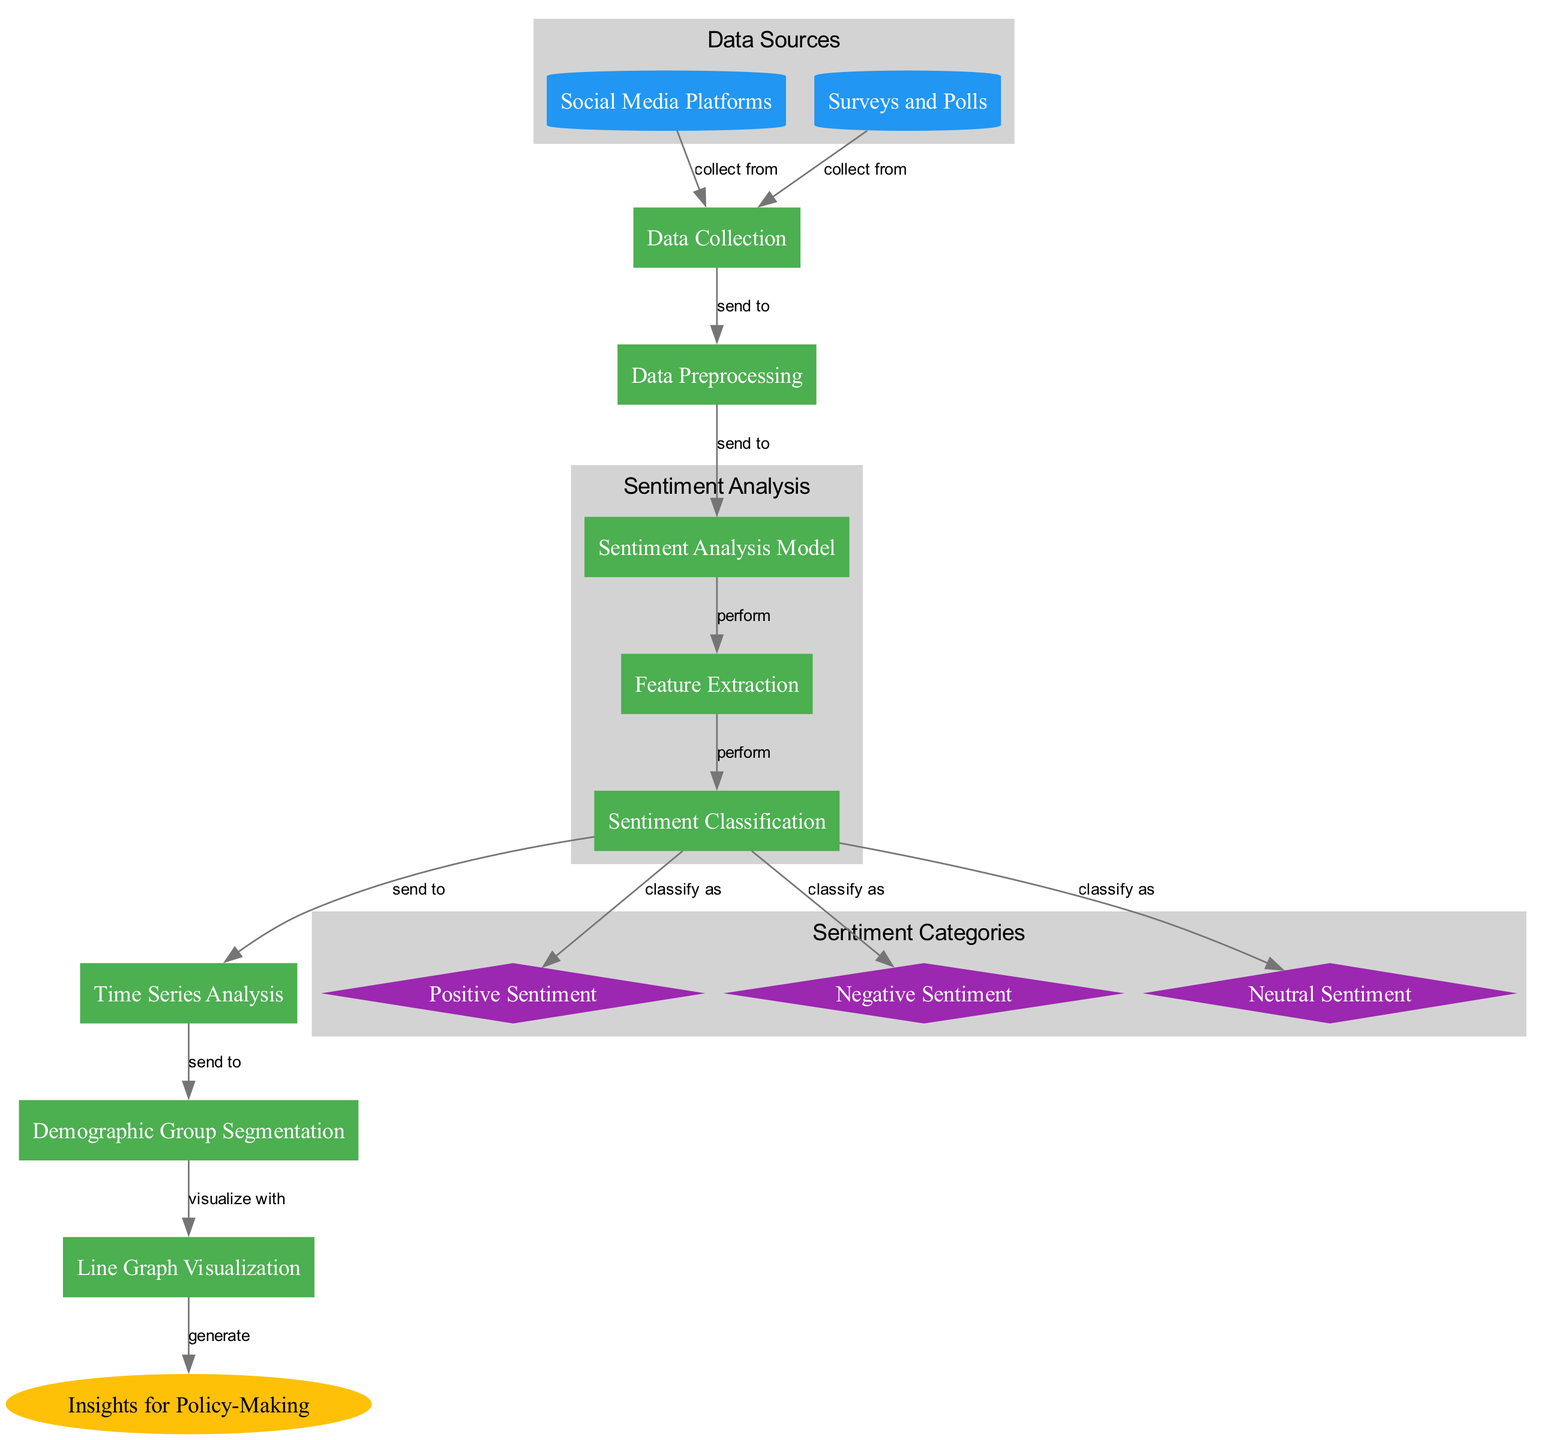What are the inputs for data collection? The diagram shows two sources from which data is collected: Social Media Platforms and Surveys and Polls. Both of these nodes feed into the Data Collection action.
Answer: Social Media Platforms and Surveys and Polls How many sentiment categories are there in the diagram? The diagram includes three categories of sentiment that are classified: Positive Sentiment, Negative Sentiment, and Neutral Sentiment. This can be counted directly from the sentiment category nodes.
Answer: Three Where does the output from the Sentiment Classification go? After classification, the Sentiment Classification action sends its output to three sentiment categories and onwards to Time Series Analysis. This indicates the flow of processed data towards the outcome node.
Answer: Time Series Analysis Which node performs feature extraction? The diagram explicitly labels the node that performs feature extraction immediately following the Sentiment Analysis Model. This indicates that feature extraction is a discrete action after model creation.
Answer: Feature Extraction What is the final outcome of the diagram's process? The final outcome is labeled as Insights for Policy-Making, which is generated from the visualization node. This indicates the purpose of the entire process depicted in the diagram.
Answer: Insights for Policy-Making How do demographic group segmentation and time series analysis relate? Demographic Group Segmentation follows Time Series Analysis. This indicates that data is segmented based on demographics after analyzing sentiments over time, suggesting a layered approach to data processing for insights.
Answer: Demographic Group Segmentation What is the process after data preprocessing? After Data Preprocessing, the process flows to the Sentiment Analysis Model, indicating that data is prepared and then sent for sentiment analysis as the next logical step.
Answer: Sentiment Analysis Model How many edges are shown in the diagram? By counting the connections between nodes, it is evident that there are 12 edges illustrated in the diagram, representing the flow of actions and processes.
Answer: Twelve 